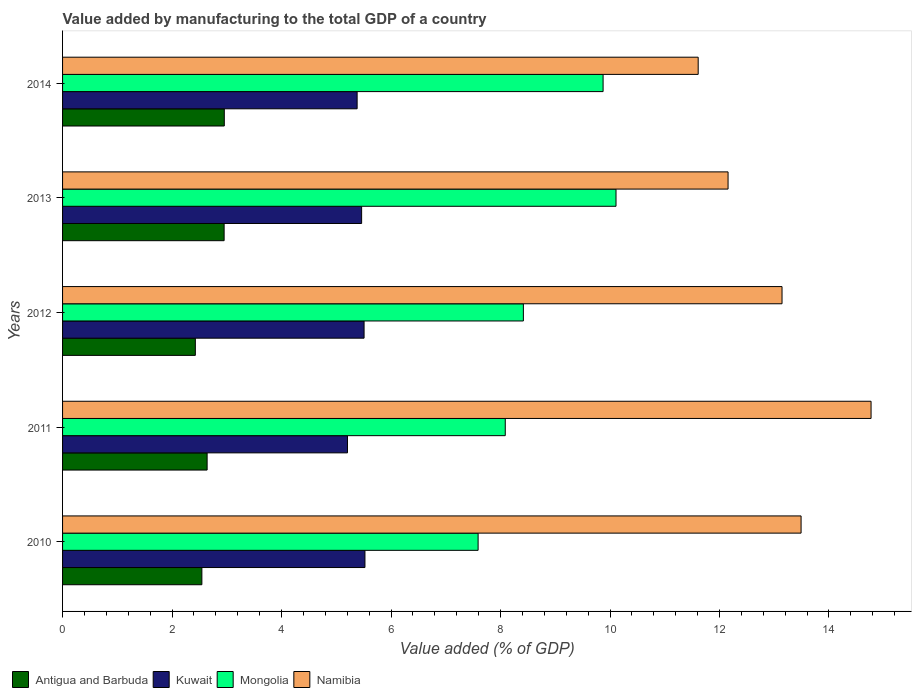How many different coloured bars are there?
Provide a succinct answer. 4. How many bars are there on the 4th tick from the bottom?
Offer a terse response. 4. What is the value added by manufacturing to the total GDP in Kuwait in 2011?
Give a very brief answer. 5.2. Across all years, what is the maximum value added by manufacturing to the total GDP in Kuwait?
Your answer should be compact. 5.52. Across all years, what is the minimum value added by manufacturing to the total GDP in Kuwait?
Keep it short and to the point. 5.2. In which year was the value added by manufacturing to the total GDP in Mongolia maximum?
Ensure brevity in your answer.  2013. What is the total value added by manufacturing to the total GDP in Mongolia in the graph?
Ensure brevity in your answer.  44.08. What is the difference between the value added by manufacturing to the total GDP in Mongolia in 2011 and that in 2014?
Your answer should be very brief. -1.79. What is the difference between the value added by manufacturing to the total GDP in Mongolia in 2014 and the value added by manufacturing to the total GDP in Kuwait in 2012?
Offer a terse response. 4.37. What is the average value added by manufacturing to the total GDP in Antigua and Barbuda per year?
Give a very brief answer. 2.7. In the year 2012, what is the difference between the value added by manufacturing to the total GDP in Antigua and Barbuda and value added by manufacturing to the total GDP in Namibia?
Offer a very short reply. -10.72. What is the ratio of the value added by manufacturing to the total GDP in Mongolia in 2010 to that in 2014?
Provide a short and direct response. 0.77. What is the difference between the highest and the second highest value added by manufacturing to the total GDP in Mongolia?
Give a very brief answer. 0.24. What is the difference between the highest and the lowest value added by manufacturing to the total GDP in Namibia?
Offer a very short reply. 3.16. Is the sum of the value added by manufacturing to the total GDP in Mongolia in 2010 and 2011 greater than the maximum value added by manufacturing to the total GDP in Antigua and Barbuda across all years?
Give a very brief answer. Yes. Is it the case that in every year, the sum of the value added by manufacturing to the total GDP in Mongolia and value added by manufacturing to the total GDP in Antigua and Barbuda is greater than the sum of value added by manufacturing to the total GDP in Kuwait and value added by manufacturing to the total GDP in Namibia?
Offer a terse response. No. What does the 1st bar from the top in 2013 represents?
Your answer should be compact. Namibia. What does the 3rd bar from the bottom in 2011 represents?
Provide a succinct answer. Mongolia. Is it the case that in every year, the sum of the value added by manufacturing to the total GDP in Mongolia and value added by manufacturing to the total GDP in Kuwait is greater than the value added by manufacturing to the total GDP in Antigua and Barbuda?
Make the answer very short. Yes. Are all the bars in the graph horizontal?
Your response must be concise. Yes. Does the graph contain any zero values?
Offer a terse response. No. Does the graph contain grids?
Ensure brevity in your answer.  No. How many legend labels are there?
Your answer should be very brief. 4. What is the title of the graph?
Provide a succinct answer. Value added by manufacturing to the total GDP of a country. Does "Honduras" appear as one of the legend labels in the graph?
Provide a short and direct response. No. What is the label or title of the X-axis?
Offer a terse response. Value added (% of GDP). What is the label or title of the Y-axis?
Your answer should be compact. Years. What is the Value added (% of GDP) of Antigua and Barbuda in 2010?
Give a very brief answer. 2.54. What is the Value added (% of GDP) of Kuwait in 2010?
Ensure brevity in your answer.  5.52. What is the Value added (% of GDP) in Mongolia in 2010?
Provide a succinct answer. 7.59. What is the Value added (% of GDP) in Namibia in 2010?
Make the answer very short. 13.49. What is the Value added (% of GDP) of Antigua and Barbuda in 2011?
Ensure brevity in your answer.  2.64. What is the Value added (% of GDP) of Kuwait in 2011?
Your answer should be compact. 5.2. What is the Value added (% of GDP) in Mongolia in 2011?
Provide a short and direct response. 8.09. What is the Value added (% of GDP) in Namibia in 2011?
Your response must be concise. 14.77. What is the Value added (% of GDP) in Antigua and Barbuda in 2012?
Offer a terse response. 2.43. What is the Value added (% of GDP) of Kuwait in 2012?
Your answer should be very brief. 5.51. What is the Value added (% of GDP) in Mongolia in 2012?
Provide a short and direct response. 8.42. What is the Value added (% of GDP) in Namibia in 2012?
Offer a terse response. 13.14. What is the Value added (% of GDP) of Antigua and Barbuda in 2013?
Provide a short and direct response. 2.95. What is the Value added (% of GDP) in Kuwait in 2013?
Offer a terse response. 5.46. What is the Value added (% of GDP) of Mongolia in 2013?
Offer a very short reply. 10.11. What is the Value added (% of GDP) in Namibia in 2013?
Make the answer very short. 12.16. What is the Value added (% of GDP) in Antigua and Barbuda in 2014?
Ensure brevity in your answer.  2.95. What is the Value added (% of GDP) of Kuwait in 2014?
Your response must be concise. 5.38. What is the Value added (% of GDP) in Mongolia in 2014?
Your answer should be very brief. 9.87. What is the Value added (% of GDP) in Namibia in 2014?
Your answer should be compact. 11.61. Across all years, what is the maximum Value added (% of GDP) in Antigua and Barbuda?
Offer a terse response. 2.95. Across all years, what is the maximum Value added (% of GDP) of Kuwait?
Your response must be concise. 5.52. Across all years, what is the maximum Value added (% of GDP) of Mongolia?
Provide a short and direct response. 10.11. Across all years, what is the maximum Value added (% of GDP) in Namibia?
Provide a short and direct response. 14.77. Across all years, what is the minimum Value added (% of GDP) in Antigua and Barbuda?
Provide a short and direct response. 2.43. Across all years, what is the minimum Value added (% of GDP) in Kuwait?
Make the answer very short. 5.2. Across all years, what is the minimum Value added (% of GDP) of Mongolia?
Your answer should be very brief. 7.59. Across all years, what is the minimum Value added (% of GDP) in Namibia?
Give a very brief answer. 11.61. What is the total Value added (% of GDP) in Antigua and Barbuda in the graph?
Your answer should be compact. 13.52. What is the total Value added (% of GDP) of Kuwait in the graph?
Give a very brief answer. 27.08. What is the total Value added (% of GDP) in Mongolia in the graph?
Your response must be concise. 44.08. What is the total Value added (% of GDP) in Namibia in the graph?
Ensure brevity in your answer.  65.17. What is the difference between the Value added (% of GDP) of Antigua and Barbuda in 2010 and that in 2011?
Your answer should be very brief. -0.1. What is the difference between the Value added (% of GDP) of Kuwait in 2010 and that in 2011?
Offer a terse response. 0.32. What is the difference between the Value added (% of GDP) in Mongolia in 2010 and that in 2011?
Make the answer very short. -0.5. What is the difference between the Value added (% of GDP) of Namibia in 2010 and that in 2011?
Keep it short and to the point. -1.28. What is the difference between the Value added (% of GDP) in Antigua and Barbuda in 2010 and that in 2012?
Offer a very short reply. 0.12. What is the difference between the Value added (% of GDP) in Kuwait in 2010 and that in 2012?
Provide a short and direct response. 0.02. What is the difference between the Value added (% of GDP) in Mongolia in 2010 and that in 2012?
Make the answer very short. -0.83. What is the difference between the Value added (% of GDP) in Namibia in 2010 and that in 2012?
Your response must be concise. 0.35. What is the difference between the Value added (% of GDP) in Antigua and Barbuda in 2010 and that in 2013?
Your response must be concise. -0.41. What is the difference between the Value added (% of GDP) of Kuwait in 2010 and that in 2013?
Give a very brief answer. 0.06. What is the difference between the Value added (% of GDP) of Mongolia in 2010 and that in 2013?
Offer a terse response. -2.52. What is the difference between the Value added (% of GDP) in Namibia in 2010 and that in 2013?
Your answer should be compact. 1.33. What is the difference between the Value added (% of GDP) of Antigua and Barbuda in 2010 and that in 2014?
Offer a very short reply. -0.41. What is the difference between the Value added (% of GDP) in Kuwait in 2010 and that in 2014?
Your answer should be very brief. 0.14. What is the difference between the Value added (% of GDP) of Mongolia in 2010 and that in 2014?
Your response must be concise. -2.28. What is the difference between the Value added (% of GDP) in Namibia in 2010 and that in 2014?
Provide a short and direct response. 1.88. What is the difference between the Value added (% of GDP) of Antigua and Barbuda in 2011 and that in 2012?
Provide a short and direct response. 0.22. What is the difference between the Value added (% of GDP) in Kuwait in 2011 and that in 2012?
Your response must be concise. -0.3. What is the difference between the Value added (% of GDP) in Mongolia in 2011 and that in 2012?
Offer a terse response. -0.33. What is the difference between the Value added (% of GDP) of Namibia in 2011 and that in 2012?
Keep it short and to the point. 1.63. What is the difference between the Value added (% of GDP) in Antigua and Barbuda in 2011 and that in 2013?
Offer a very short reply. -0.31. What is the difference between the Value added (% of GDP) of Kuwait in 2011 and that in 2013?
Keep it short and to the point. -0.26. What is the difference between the Value added (% of GDP) of Mongolia in 2011 and that in 2013?
Provide a succinct answer. -2.02. What is the difference between the Value added (% of GDP) in Namibia in 2011 and that in 2013?
Offer a terse response. 2.61. What is the difference between the Value added (% of GDP) of Antigua and Barbuda in 2011 and that in 2014?
Offer a very short reply. -0.31. What is the difference between the Value added (% of GDP) of Kuwait in 2011 and that in 2014?
Your answer should be compact. -0.18. What is the difference between the Value added (% of GDP) of Mongolia in 2011 and that in 2014?
Your answer should be compact. -1.79. What is the difference between the Value added (% of GDP) of Namibia in 2011 and that in 2014?
Your answer should be very brief. 3.16. What is the difference between the Value added (% of GDP) in Antigua and Barbuda in 2012 and that in 2013?
Your response must be concise. -0.53. What is the difference between the Value added (% of GDP) of Kuwait in 2012 and that in 2013?
Provide a succinct answer. 0.04. What is the difference between the Value added (% of GDP) of Mongolia in 2012 and that in 2013?
Keep it short and to the point. -1.69. What is the difference between the Value added (% of GDP) of Namibia in 2012 and that in 2013?
Your answer should be very brief. 0.99. What is the difference between the Value added (% of GDP) in Antigua and Barbuda in 2012 and that in 2014?
Make the answer very short. -0.53. What is the difference between the Value added (% of GDP) of Kuwait in 2012 and that in 2014?
Your answer should be very brief. 0.13. What is the difference between the Value added (% of GDP) in Mongolia in 2012 and that in 2014?
Offer a very short reply. -1.46. What is the difference between the Value added (% of GDP) in Namibia in 2012 and that in 2014?
Ensure brevity in your answer.  1.53. What is the difference between the Value added (% of GDP) of Antigua and Barbuda in 2013 and that in 2014?
Provide a succinct answer. -0. What is the difference between the Value added (% of GDP) of Kuwait in 2013 and that in 2014?
Offer a terse response. 0.08. What is the difference between the Value added (% of GDP) in Mongolia in 2013 and that in 2014?
Give a very brief answer. 0.24. What is the difference between the Value added (% of GDP) of Namibia in 2013 and that in 2014?
Offer a very short reply. 0.55. What is the difference between the Value added (% of GDP) of Antigua and Barbuda in 2010 and the Value added (% of GDP) of Kuwait in 2011?
Offer a very short reply. -2.66. What is the difference between the Value added (% of GDP) of Antigua and Barbuda in 2010 and the Value added (% of GDP) of Mongolia in 2011?
Your response must be concise. -5.54. What is the difference between the Value added (% of GDP) of Antigua and Barbuda in 2010 and the Value added (% of GDP) of Namibia in 2011?
Your response must be concise. -12.22. What is the difference between the Value added (% of GDP) of Kuwait in 2010 and the Value added (% of GDP) of Mongolia in 2011?
Your answer should be compact. -2.56. What is the difference between the Value added (% of GDP) of Kuwait in 2010 and the Value added (% of GDP) of Namibia in 2011?
Your response must be concise. -9.25. What is the difference between the Value added (% of GDP) of Mongolia in 2010 and the Value added (% of GDP) of Namibia in 2011?
Provide a succinct answer. -7.18. What is the difference between the Value added (% of GDP) in Antigua and Barbuda in 2010 and the Value added (% of GDP) in Kuwait in 2012?
Give a very brief answer. -2.96. What is the difference between the Value added (% of GDP) in Antigua and Barbuda in 2010 and the Value added (% of GDP) in Mongolia in 2012?
Offer a terse response. -5.87. What is the difference between the Value added (% of GDP) in Antigua and Barbuda in 2010 and the Value added (% of GDP) in Namibia in 2012?
Your response must be concise. -10.6. What is the difference between the Value added (% of GDP) of Kuwait in 2010 and the Value added (% of GDP) of Mongolia in 2012?
Your response must be concise. -2.89. What is the difference between the Value added (% of GDP) in Kuwait in 2010 and the Value added (% of GDP) in Namibia in 2012?
Give a very brief answer. -7.62. What is the difference between the Value added (% of GDP) of Mongolia in 2010 and the Value added (% of GDP) of Namibia in 2012?
Ensure brevity in your answer.  -5.55. What is the difference between the Value added (% of GDP) of Antigua and Barbuda in 2010 and the Value added (% of GDP) of Kuwait in 2013?
Provide a short and direct response. -2.92. What is the difference between the Value added (% of GDP) in Antigua and Barbuda in 2010 and the Value added (% of GDP) in Mongolia in 2013?
Your response must be concise. -7.56. What is the difference between the Value added (% of GDP) in Antigua and Barbuda in 2010 and the Value added (% of GDP) in Namibia in 2013?
Your response must be concise. -9.61. What is the difference between the Value added (% of GDP) in Kuwait in 2010 and the Value added (% of GDP) in Mongolia in 2013?
Offer a terse response. -4.59. What is the difference between the Value added (% of GDP) of Kuwait in 2010 and the Value added (% of GDP) of Namibia in 2013?
Make the answer very short. -6.63. What is the difference between the Value added (% of GDP) in Mongolia in 2010 and the Value added (% of GDP) in Namibia in 2013?
Provide a short and direct response. -4.57. What is the difference between the Value added (% of GDP) of Antigua and Barbuda in 2010 and the Value added (% of GDP) of Kuwait in 2014?
Ensure brevity in your answer.  -2.84. What is the difference between the Value added (% of GDP) of Antigua and Barbuda in 2010 and the Value added (% of GDP) of Mongolia in 2014?
Make the answer very short. -7.33. What is the difference between the Value added (% of GDP) of Antigua and Barbuda in 2010 and the Value added (% of GDP) of Namibia in 2014?
Offer a terse response. -9.07. What is the difference between the Value added (% of GDP) of Kuwait in 2010 and the Value added (% of GDP) of Mongolia in 2014?
Your response must be concise. -4.35. What is the difference between the Value added (% of GDP) of Kuwait in 2010 and the Value added (% of GDP) of Namibia in 2014?
Offer a terse response. -6.09. What is the difference between the Value added (% of GDP) of Mongolia in 2010 and the Value added (% of GDP) of Namibia in 2014?
Your answer should be compact. -4.02. What is the difference between the Value added (% of GDP) in Antigua and Barbuda in 2011 and the Value added (% of GDP) in Kuwait in 2012?
Give a very brief answer. -2.87. What is the difference between the Value added (% of GDP) in Antigua and Barbuda in 2011 and the Value added (% of GDP) in Mongolia in 2012?
Your response must be concise. -5.78. What is the difference between the Value added (% of GDP) in Antigua and Barbuda in 2011 and the Value added (% of GDP) in Namibia in 2012?
Provide a short and direct response. -10.5. What is the difference between the Value added (% of GDP) in Kuwait in 2011 and the Value added (% of GDP) in Mongolia in 2012?
Your answer should be very brief. -3.21. What is the difference between the Value added (% of GDP) in Kuwait in 2011 and the Value added (% of GDP) in Namibia in 2012?
Provide a short and direct response. -7.94. What is the difference between the Value added (% of GDP) in Mongolia in 2011 and the Value added (% of GDP) in Namibia in 2012?
Provide a short and direct response. -5.06. What is the difference between the Value added (% of GDP) in Antigua and Barbuda in 2011 and the Value added (% of GDP) in Kuwait in 2013?
Give a very brief answer. -2.82. What is the difference between the Value added (% of GDP) in Antigua and Barbuda in 2011 and the Value added (% of GDP) in Mongolia in 2013?
Your answer should be very brief. -7.47. What is the difference between the Value added (% of GDP) of Antigua and Barbuda in 2011 and the Value added (% of GDP) of Namibia in 2013?
Your answer should be very brief. -9.52. What is the difference between the Value added (% of GDP) in Kuwait in 2011 and the Value added (% of GDP) in Mongolia in 2013?
Provide a short and direct response. -4.91. What is the difference between the Value added (% of GDP) in Kuwait in 2011 and the Value added (% of GDP) in Namibia in 2013?
Offer a very short reply. -6.95. What is the difference between the Value added (% of GDP) of Mongolia in 2011 and the Value added (% of GDP) of Namibia in 2013?
Make the answer very short. -4.07. What is the difference between the Value added (% of GDP) of Antigua and Barbuda in 2011 and the Value added (% of GDP) of Kuwait in 2014?
Your answer should be compact. -2.74. What is the difference between the Value added (% of GDP) of Antigua and Barbuda in 2011 and the Value added (% of GDP) of Mongolia in 2014?
Provide a short and direct response. -7.23. What is the difference between the Value added (% of GDP) in Antigua and Barbuda in 2011 and the Value added (% of GDP) in Namibia in 2014?
Keep it short and to the point. -8.97. What is the difference between the Value added (% of GDP) of Kuwait in 2011 and the Value added (% of GDP) of Mongolia in 2014?
Give a very brief answer. -4.67. What is the difference between the Value added (% of GDP) of Kuwait in 2011 and the Value added (% of GDP) of Namibia in 2014?
Your response must be concise. -6.41. What is the difference between the Value added (% of GDP) of Mongolia in 2011 and the Value added (% of GDP) of Namibia in 2014?
Provide a short and direct response. -3.52. What is the difference between the Value added (% of GDP) of Antigua and Barbuda in 2012 and the Value added (% of GDP) of Kuwait in 2013?
Give a very brief answer. -3.04. What is the difference between the Value added (% of GDP) in Antigua and Barbuda in 2012 and the Value added (% of GDP) in Mongolia in 2013?
Your answer should be compact. -7.68. What is the difference between the Value added (% of GDP) of Antigua and Barbuda in 2012 and the Value added (% of GDP) of Namibia in 2013?
Offer a very short reply. -9.73. What is the difference between the Value added (% of GDP) of Kuwait in 2012 and the Value added (% of GDP) of Mongolia in 2013?
Offer a terse response. -4.6. What is the difference between the Value added (% of GDP) in Kuwait in 2012 and the Value added (% of GDP) in Namibia in 2013?
Your response must be concise. -6.65. What is the difference between the Value added (% of GDP) of Mongolia in 2012 and the Value added (% of GDP) of Namibia in 2013?
Your response must be concise. -3.74. What is the difference between the Value added (% of GDP) of Antigua and Barbuda in 2012 and the Value added (% of GDP) of Kuwait in 2014?
Provide a short and direct response. -2.96. What is the difference between the Value added (% of GDP) of Antigua and Barbuda in 2012 and the Value added (% of GDP) of Mongolia in 2014?
Offer a very short reply. -7.45. What is the difference between the Value added (% of GDP) of Antigua and Barbuda in 2012 and the Value added (% of GDP) of Namibia in 2014?
Keep it short and to the point. -9.19. What is the difference between the Value added (% of GDP) in Kuwait in 2012 and the Value added (% of GDP) in Mongolia in 2014?
Provide a short and direct response. -4.37. What is the difference between the Value added (% of GDP) of Kuwait in 2012 and the Value added (% of GDP) of Namibia in 2014?
Your response must be concise. -6.1. What is the difference between the Value added (% of GDP) in Mongolia in 2012 and the Value added (% of GDP) in Namibia in 2014?
Give a very brief answer. -3.19. What is the difference between the Value added (% of GDP) of Antigua and Barbuda in 2013 and the Value added (% of GDP) of Kuwait in 2014?
Keep it short and to the point. -2.43. What is the difference between the Value added (% of GDP) of Antigua and Barbuda in 2013 and the Value added (% of GDP) of Mongolia in 2014?
Provide a short and direct response. -6.92. What is the difference between the Value added (% of GDP) in Antigua and Barbuda in 2013 and the Value added (% of GDP) in Namibia in 2014?
Your response must be concise. -8.66. What is the difference between the Value added (% of GDP) of Kuwait in 2013 and the Value added (% of GDP) of Mongolia in 2014?
Your answer should be compact. -4.41. What is the difference between the Value added (% of GDP) in Kuwait in 2013 and the Value added (% of GDP) in Namibia in 2014?
Your answer should be very brief. -6.15. What is the difference between the Value added (% of GDP) of Mongolia in 2013 and the Value added (% of GDP) of Namibia in 2014?
Make the answer very short. -1.5. What is the average Value added (% of GDP) in Antigua and Barbuda per year?
Give a very brief answer. 2.7. What is the average Value added (% of GDP) of Kuwait per year?
Your answer should be very brief. 5.42. What is the average Value added (% of GDP) in Mongolia per year?
Give a very brief answer. 8.82. What is the average Value added (% of GDP) of Namibia per year?
Make the answer very short. 13.03. In the year 2010, what is the difference between the Value added (% of GDP) of Antigua and Barbuda and Value added (% of GDP) of Kuwait?
Provide a succinct answer. -2.98. In the year 2010, what is the difference between the Value added (% of GDP) in Antigua and Barbuda and Value added (% of GDP) in Mongolia?
Provide a succinct answer. -5.05. In the year 2010, what is the difference between the Value added (% of GDP) in Antigua and Barbuda and Value added (% of GDP) in Namibia?
Provide a short and direct response. -10.95. In the year 2010, what is the difference between the Value added (% of GDP) of Kuwait and Value added (% of GDP) of Mongolia?
Make the answer very short. -2.07. In the year 2010, what is the difference between the Value added (% of GDP) of Kuwait and Value added (% of GDP) of Namibia?
Provide a succinct answer. -7.97. In the year 2010, what is the difference between the Value added (% of GDP) of Mongolia and Value added (% of GDP) of Namibia?
Your response must be concise. -5.9. In the year 2011, what is the difference between the Value added (% of GDP) of Antigua and Barbuda and Value added (% of GDP) of Kuwait?
Offer a terse response. -2.56. In the year 2011, what is the difference between the Value added (% of GDP) of Antigua and Barbuda and Value added (% of GDP) of Mongolia?
Provide a short and direct response. -5.45. In the year 2011, what is the difference between the Value added (% of GDP) of Antigua and Barbuda and Value added (% of GDP) of Namibia?
Offer a terse response. -12.13. In the year 2011, what is the difference between the Value added (% of GDP) in Kuwait and Value added (% of GDP) in Mongolia?
Keep it short and to the point. -2.88. In the year 2011, what is the difference between the Value added (% of GDP) in Kuwait and Value added (% of GDP) in Namibia?
Give a very brief answer. -9.56. In the year 2011, what is the difference between the Value added (% of GDP) of Mongolia and Value added (% of GDP) of Namibia?
Make the answer very short. -6.68. In the year 2012, what is the difference between the Value added (% of GDP) in Antigua and Barbuda and Value added (% of GDP) in Kuwait?
Your answer should be very brief. -3.08. In the year 2012, what is the difference between the Value added (% of GDP) of Antigua and Barbuda and Value added (% of GDP) of Mongolia?
Your response must be concise. -5.99. In the year 2012, what is the difference between the Value added (% of GDP) in Antigua and Barbuda and Value added (% of GDP) in Namibia?
Keep it short and to the point. -10.72. In the year 2012, what is the difference between the Value added (% of GDP) of Kuwait and Value added (% of GDP) of Mongolia?
Your answer should be very brief. -2.91. In the year 2012, what is the difference between the Value added (% of GDP) of Kuwait and Value added (% of GDP) of Namibia?
Provide a short and direct response. -7.63. In the year 2012, what is the difference between the Value added (% of GDP) of Mongolia and Value added (% of GDP) of Namibia?
Offer a terse response. -4.72. In the year 2013, what is the difference between the Value added (% of GDP) of Antigua and Barbuda and Value added (% of GDP) of Kuwait?
Your answer should be compact. -2.51. In the year 2013, what is the difference between the Value added (% of GDP) in Antigua and Barbuda and Value added (% of GDP) in Mongolia?
Provide a short and direct response. -7.16. In the year 2013, what is the difference between the Value added (% of GDP) in Antigua and Barbuda and Value added (% of GDP) in Namibia?
Offer a terse response. -9.21. In the year 2013, what is the difference between the Value added (% of GDP) of Kuwait and Value added (% of GDP) of Mongolia?
Your answer should be very brief. -4.65. In the year 2013, what is the difference between the Value added (% of GDP) in Kuwait and Value added (% of GDP) in Namibia?
Provide a short and direct response. -6.69. In the year 2013, what is the difference between the Value added (% of GDP) in Mongolia and Value added (% of GDP) in Namibia?
Ensure brevity in your answer.  -2.05. In the year 2014, what is the difference between the Value added (% of GDP) in Antigua and Barbuda and Value added (% of GDP) in Kuwait?
Offer a terse response. -2.43. In the year 2014, what is the difference between the Value added (% of GDP) in Antigua and Barbuda and Value added (% of GDP) in Mongolia?
Ensure brevity in your answer.  -6.92. In the year 2014, what is the difference between the Value added (% of GDP) in Antigua and Barbuda and Value added (% of GDP) in Namibia?
Give a very brief answer. -8.66. In the year 2014, what is the difference between the Value added (% of GDP) in Kuwait and Value added (% of GDP) in Mongolia?
Give a very brief answer. -4.49. In the year 2014, what is the difference between the Value added (% of GDP) in Kuwait and Value added (% of GDP) in Namibia?
Your answer should be compact. -6.23. In the year 2014, what is the difference between the Value added (% of GDP) of Mongolia and Value added (% of GDP) of Namibia?
Offer a very short reply. -1.74. What is the ratio of the Value added (% of GDP) of Antigua and Barbuda in 2010 to that in 2011?
Offer a terse response. 0.96. What is the ratio of the Value added (% of GDP) of Kuwait in 2010 to that in 2011?
Offer a very short reply. 1.06. What is the ratio of the Value added (% of GDP) of Mongolia in 2010 to that in 2011?
Your answer should be very brief. 0.94. What is the ratio of the Value added (% of GDP) of Namibia in 2010 to that in 2011?
Provide a succinct answer. 0.91. What is the ratio of the Value added (% of GDP) in Antigua and Barbuda in 2010 to that in 2012?
Provide a short and direct response. 1.05. What is the ratio of the Value added (% of GDP) of Mongolia in 2010 to that in 2012?
Keep it short and to the point. 0.9. What is the ratio of the Value added (% of GDP) in Namibia in 2010 to that in 2012?
Offer a terse response. 1.03. What is the ratio of the Value added (% of GDP) in Antigua and Barbuda in 2010 to that in 2013?
Keep it short and to the point. 0.86. What is the ratio of the Value added (% of GDP) in Kuwait in 2010 to that in 2013?
Offer a terse response. 1.01. What is the ratio of the Value added (% of GDP) of Mongolia in 2010 to that in 2013?
Offer a terse response. 0.75. What is the ratio of the Value added (% of GDP) in Namibia in 2010 to that in 2013?
Ensure brevity in your answer.  1.11. What is the ratio of the Value added (% of GDP) of Antigua and Barbuda in 2010 to that in 2014?
Provide a short and direct response. 0.86. What is the ratio of the Value added (% of GDP) of Kuwait in 2010 to that in 2014?
Your answer should be very brief. 1.03. What is the ratio of the Value added (% of GDP) in Mongolia in 2010 to that in 2014?
Your answer should be very brief. 0.77. What is the ratio of the Value added (% of GDP) of Namibia in 2010 to that in 2014?
Provide a short and direct response. 1.16. What is the ratio of the Value added (% of GDP) in Antigua and Barbuda in 2011 to that in 2012?
Offer a terse response. 1.09. What is the ratio of the Value added (% of GDP) in Kuwait in 2011 to that in 2012?
Give a very brief answer. 0.94. What is the ratio of the Value added (% of GDP) of Mongolia in 2011 to that in 2012?
Give a very brief answer. 0.96. What is the ratio of the Value added (% of GDP) in Namibia in 2011 to that in 2012?
Provide a short and direct response. 1.12. What is the ratio of the Value added (% of GDP) of Antigua and Barbuda in 2011 to that in 2013?
Your answer should be very brief. 0.89. What is the ratio of the Value added (% of GDP) in Kuwait in 2011 to that in 2013?
Keep it short and to the point. 0.95. What is the ratio of the Value added (% of GDP) of Mongolia in 2011 to that in 2013?
Provide a succinct answer. 0.8. What is the ratio of the Value added (% of GDP) in Namibia in 2011 to that in 2013?
Provide a short and direct response. 1.21. What is the ratio of the Value added (% of GDP) of Antigua and Barbuda in 2011 to that in 2014?
Your answer should be very brief. 0.89. What is the ratio of the Value added (% of GDP) of Kuwait in 2011 to that in 2014?
Your response must be concise. 0.97. What is the ratio of the Value added (% of GDP) in Mongolia in 2011 to that in 2014?
Provide a short and direct response. 0.82. What is the ratio of the Value added (% of GDP) in Namibia in 2011 to that in 2014?
Offer a terse response. 1.27. What is the ratio of the Value added (% of GDP) of Antigua and Barbuda in 2012 to that in 2013?
Your response must be concise. 0.82. What is the ratio of the Value added (% of GDP) of Kuwait in 2012 to that in 2013?
Your answer should be compact. 1.01. What is the ratio of the Value added (% of GDP) of Mongolia in 2012 to that in 2013?
Offer a terse response. 0.83. What is the ratio of the Value added (% of GDP) in Namibia in 2012 to that in 2013?
Provide a short and direct response. 1.08. What is the ratio of the Value added (% of GDP) in Antigua and Barbuda in 2012 to that in 2014?
Offer a terse response. 0.82. What is the ratio of the Value added (% of GDP) in Kuwait in 2012 to that in 2014?
Give a very brief answer. 1.02. What is the ratio of the Value added (% of GDP) of Mongolia in 2012 to that in 2014?
Ensure brevity in your answer.  0.85. What is the ratio of the Value added (% of GDP) of Namibia in 2012 to that in 2014?
Make the answer very short. 1.13. What is the ratio of the Value added (% of GDP) of Kuwait in 2013 to that in 2014?
Provide a succinct answer. 1.02. What is the ratio of the Value added (% of GDP) of Mongolia in 2013 to that in 2014?
Offer a terse response. 1.02. What is the ratio of the Value added (% of GDP) in Namibia in 2013 to that in 2014?
Your response must be concise. 1.05. What is the difference between the highest and the second highest Value added (% of GDP) of Antigua and Barbuda?
Your response must be concise. 0. What is the difference between the highest and the second highest Value added (% of GDP) in Kuwait?
Your response must be concise. 0.02. What is the difference between the highest and the second highest Value added (% of GDP) in Mongolia?
Provide a succinct answer. 0.24. What is the difference between the highest and the second highest Value added (% of GDP) in Namibia?
Your response must be concise. 1.28. What is the difference between the highest and the lowest Value added (% of GDP) of Antigua and Barbuda?
Provide a short and direct response. 0.53. What is the difference between the highest and the lowest Value added (% of GDP) of Kuwait?
Provide a short and direct response. 0.32. What is the difference between the highest and the lowest Value added (% of GDP) of Mongolia?
Your answer should be compact. 2.52. What is the difference between the highest and the lowest Value added (% of GDP) in Namibia?
Your answer should be compact. 3.16. 